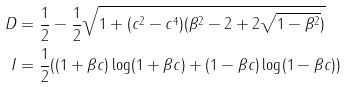<formula> <loc_0><loc_0><loc_500><loc_500>D & = \frac { 1 } { 2 } - \frac { 1 } { 2 } \sqrt { 1 + ( c ^ { 2 } - c ^ { 4 } ) ( \beta ^ { 2 } - 2 + 2 \sqrt { 1 - \beta ^ { 2 } } ) } \\ I & = \frac { 1 } { 2 } ( ( 1 + \beta c ) \log ( 1 + \beta c ) + ( 1 - \beta c ) \log ( 1 - \beta c ) )</formula> 